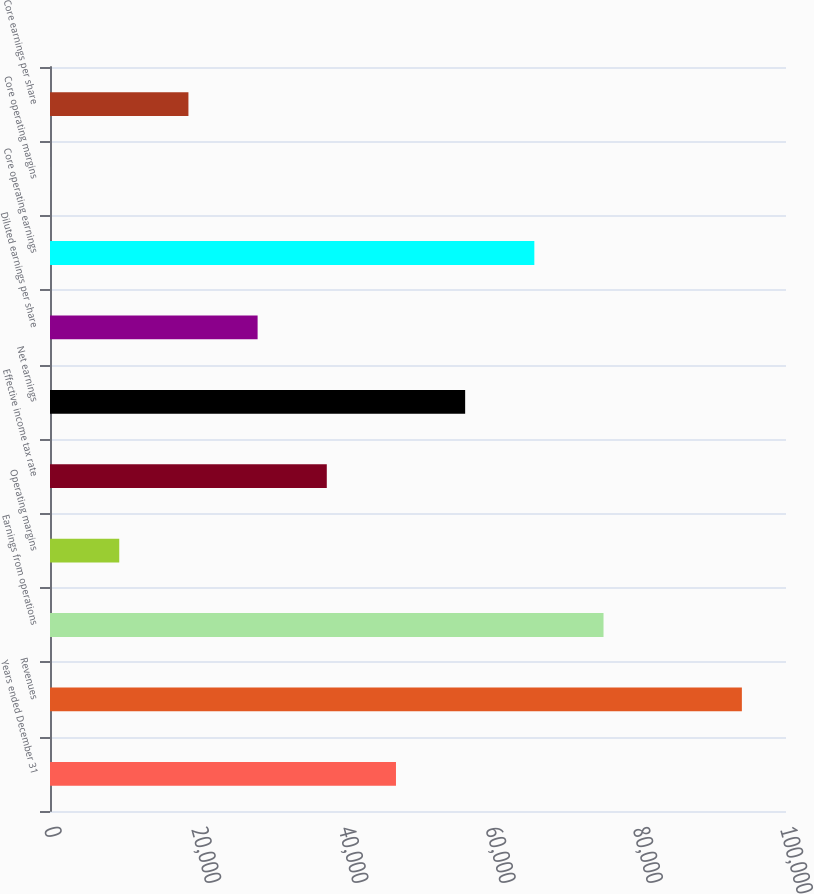<chart> <loc_0><loc_0><loc_500><loc_500><bar_chart><fcel>Years ended December 31<fcel>Revenues<fcel>Earnings from operations<fcel>Operating margins<fcel>Effective income tax rate<fcel>Net earnings<fcel>Diluted earnings per share<fcel>Core operating earnings<fcel>Core operating margins<fcel>Core earnings per share<nl><fcel>47007.2<fcel>94005<fcel>75205.9<fcel>9409.05<fcel>37607.7<fcel>56406.8<fcel>28208.2<fcel>65806.4<fcel>9.5<fcel>18808.6<nl></chart> 